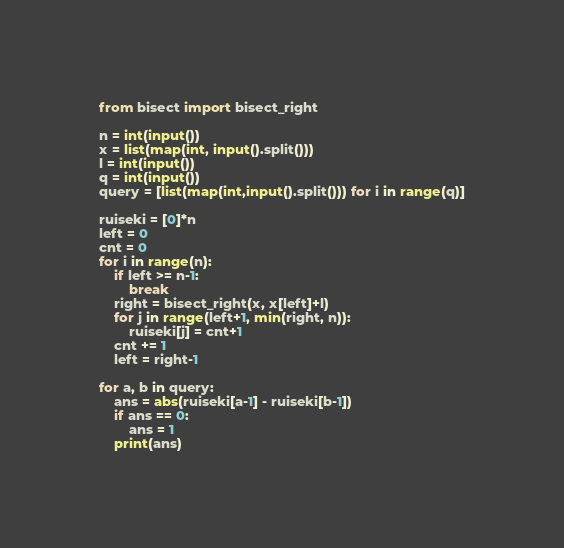Convert code to text. <code><loc_0><loc_0><loc_500><loc_500><_Python_>from bisect import bisect_right

n = int(input())
x = list(map(int, input().split()))
l = int(input())
q = int(input())
query = [list(map(int,input().split())) for i in range(q)]

ruiseki = [0]*n
left = 0
cnt = 0
for i in range(n):
    if left >= n-1:
        break
    right = bisect_right(x, x[left]+l)
    for j in range(left+1, min(right, n)):
        ruiseki[j] = cnt+1
    cnt += 1
    left = right-1

for a, b in query:
    ans = abs(ruiseki[a-1] - ruiseki[b-1])
    if ans == 0:
        ans = 1
    print(ans)</code> 